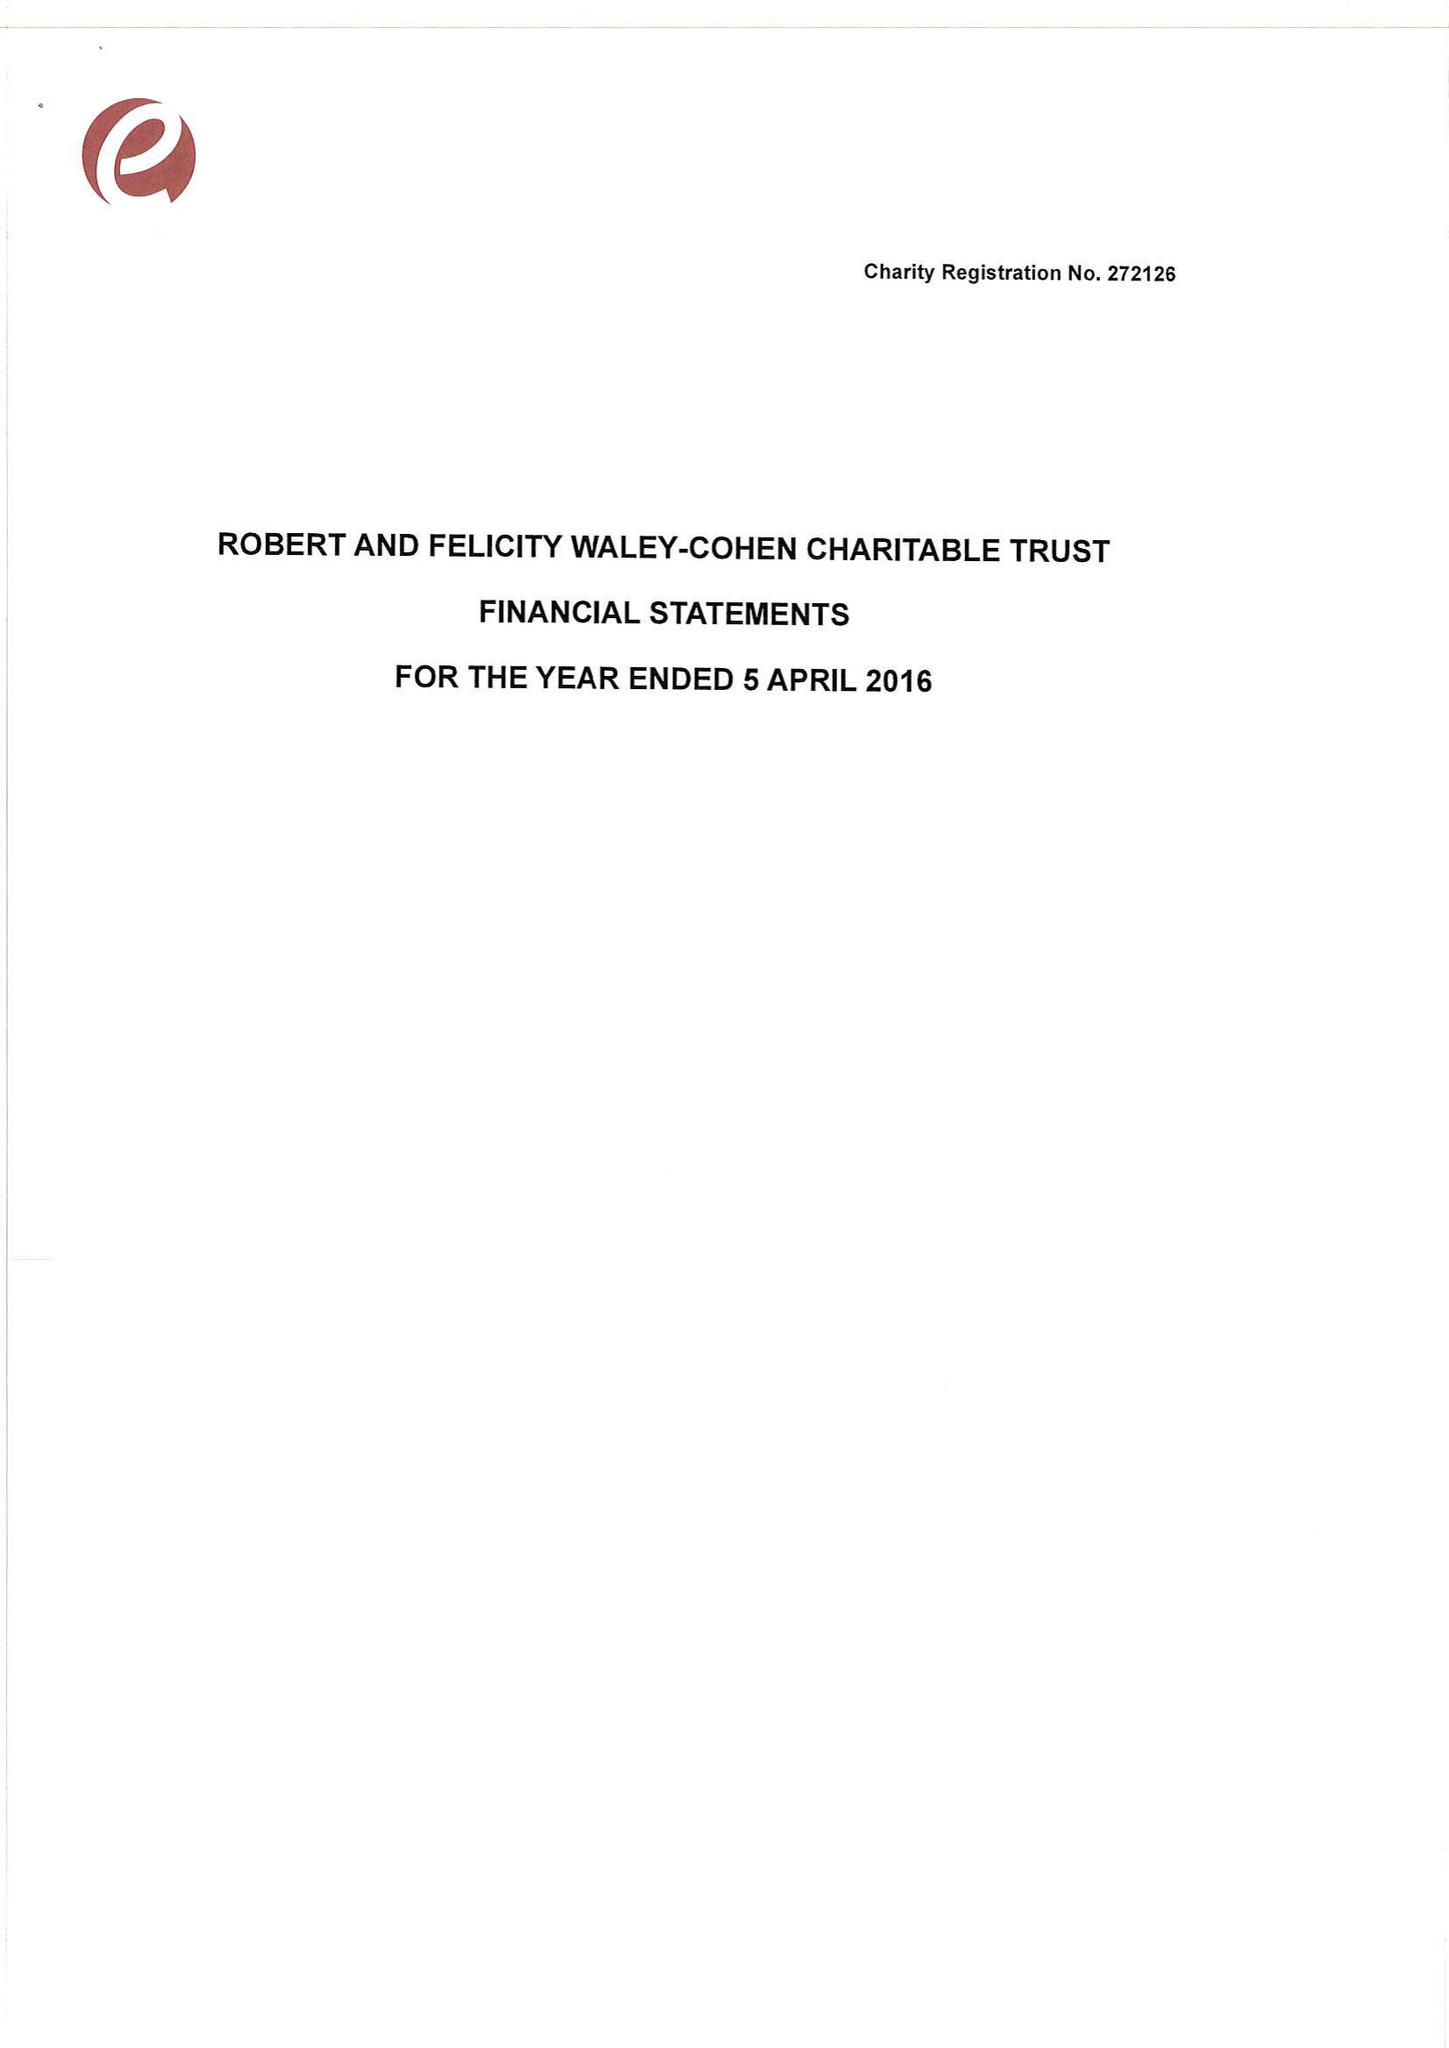What is the value for the address__postcode?
Answer the question using a single word or phrase. SW7 2TB 